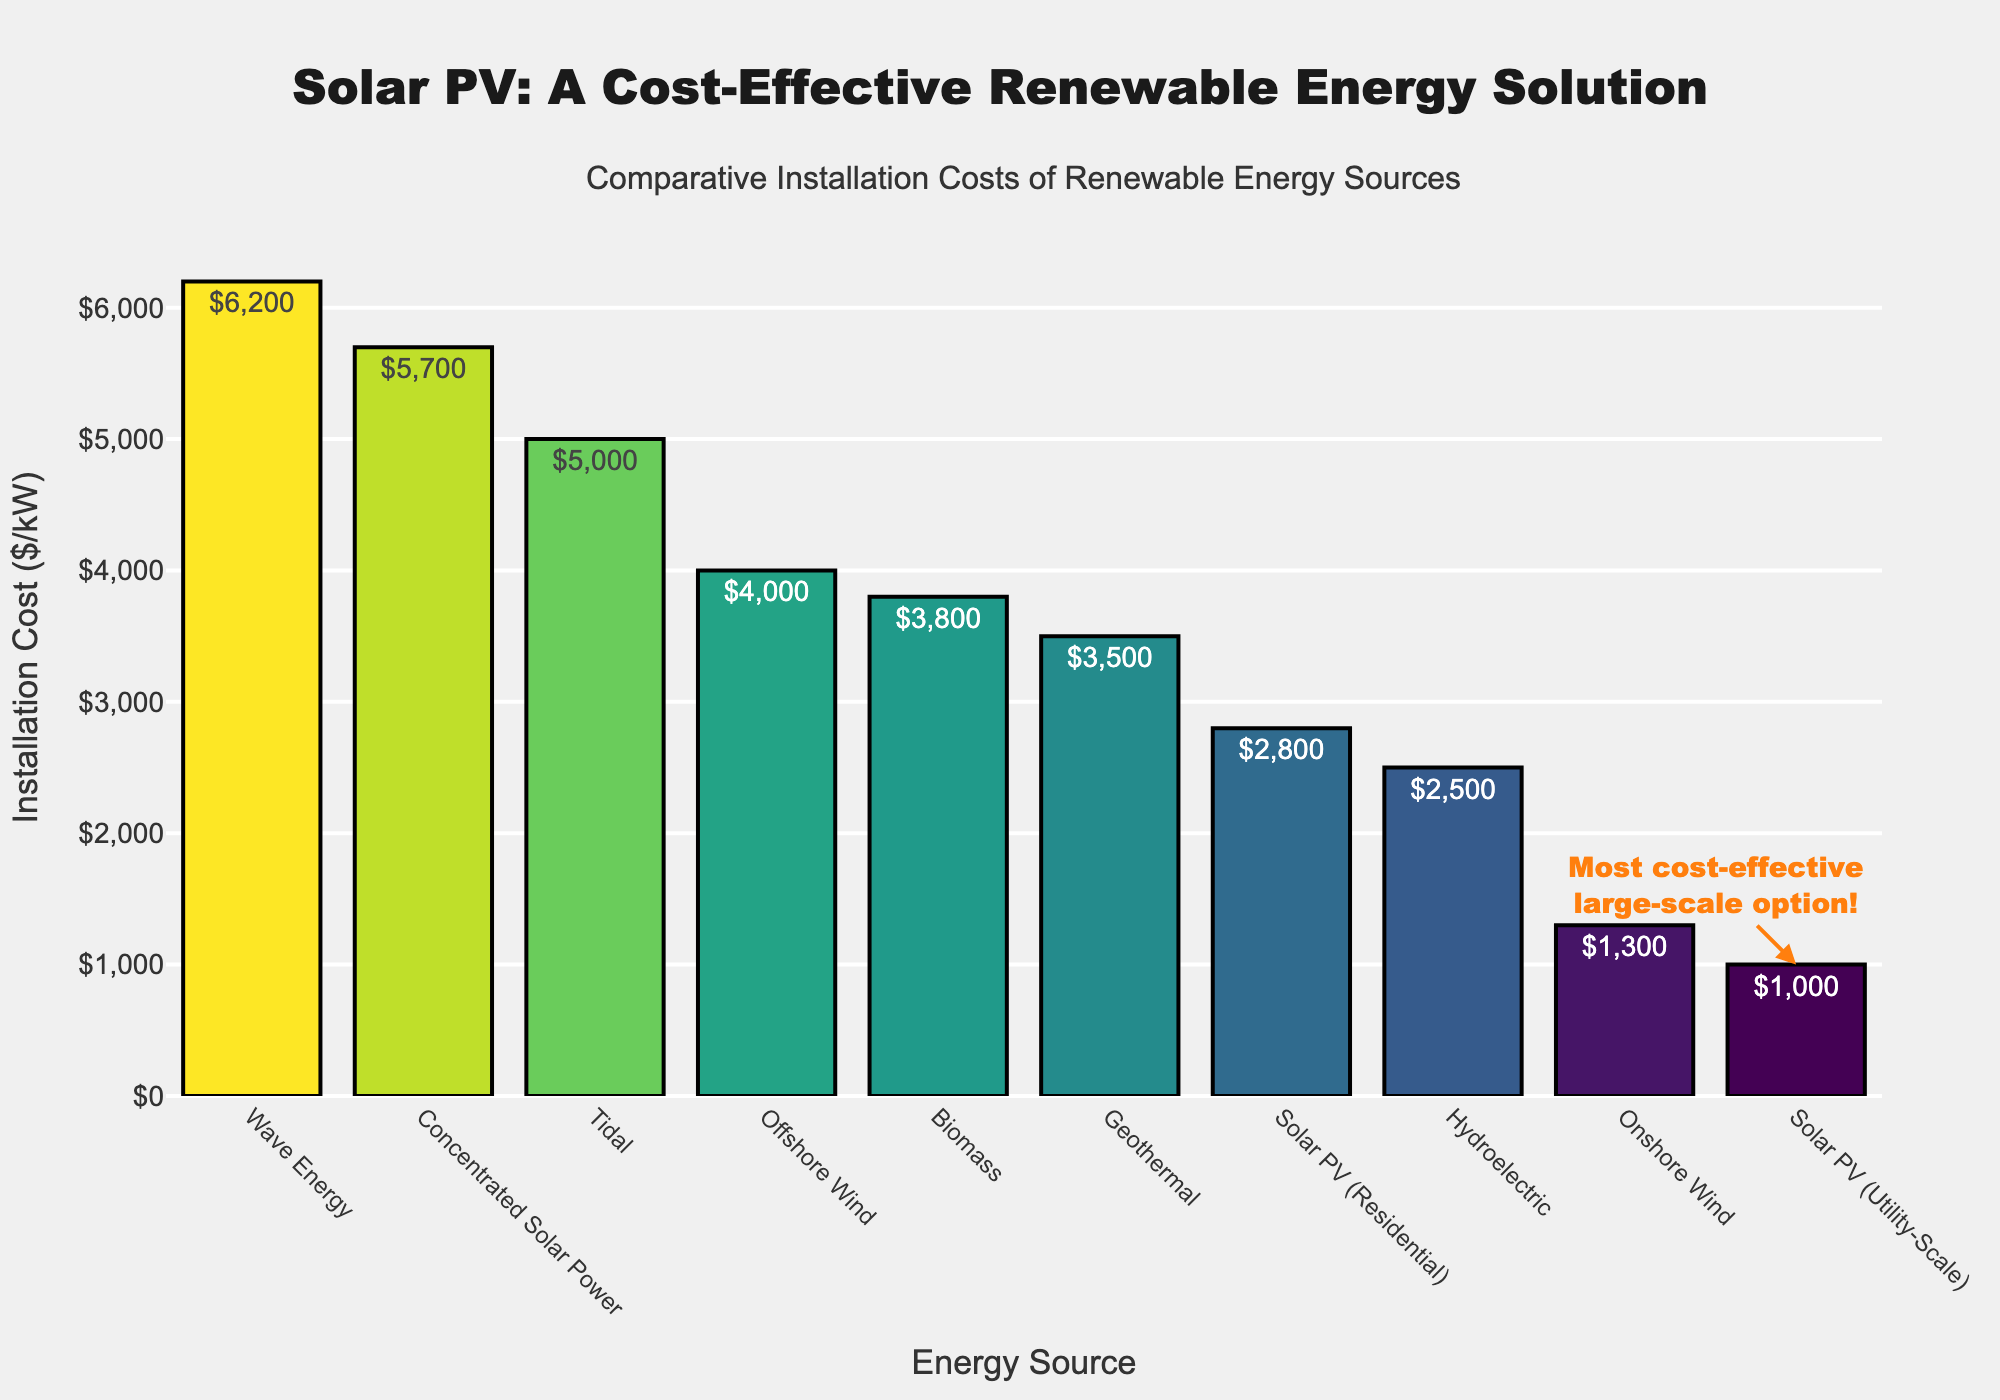What is the total installation cost for Solar PV (Utility-Scale) and Solar PV (Residential)? To find the total installation cost, add the costs for Solar PV (Utility-Scale) and Solar PV (Residential). That is $1000/kW + $2800/kW = $3800/kW.
Answer: $3800/kW Which energy source has the highest installation cost? By looking at the heights of the bars, Wave Energy has the tallest bar indicating it has the highest installation cost.
Answer: Wave Energy How much higher is the installation cost of Wave Energy compared to Onshore Wind? Wave Energy has an installation cost of $6200/kW and Onshore Wind has $1300/kW. The difference is $6200/kW - $1300/kW = $4900/kW.
Answer: $4900/kW Which energy source is most cost-effective for large-scale installations? According to the annotation in the plot, Solar PV (Utility-Scale) is highlighted as the most cost-effective large-scale option.
Answer: Solar PV (Utility-Scale) What is the average installation cost of all the renewable energy sources listed? To calculate the average, sum all the installation costs and divide by the number of sources: ($1000 + $2800 + $1300 + $4000 + $2500 + $3500 + $3800 + $5700 + $5000 + $6200) / 10 = $35,800 / 10 = $3580/kW.
Answer: $3580/kW How does the installation cost of Concentrated Solar Power compare to Hydroelectric? Concentrated Solar Power has an installation cost of $5700/kW, while Hydroelectric has $2500/kW. Thus, Concentrated Solar Power is $5700/kW - $2500/kW = $3200/kW more expensive.
Answer: $3200/kW more expensive Which energy sources have installation costs greater than $3000/kW? By inspecting the bars with heights above the $3000/kW mark, the energy sources are Offshore Wind, Geothermal, Biomass, Concentrated Solar Power, Tidal, and Wave Energy.
Answer: Offshore Wind, Geothermal, Biomass, Concentrated Solar Power, Tidal, Wave Energy What is the relative difference in cost between Solar PV (Residential) and Geothermal? Solar PV (Residential) has an installation cost of $2800/kW, and Geothermal has $3500/kW. The relative difference is ($3500 - $2800) / $2800 x 100% ≈ 25%.
Answer: ≈ 25% What is the median installation cost of the listed renewable energy sources? To find the median, the installation costs must be ordered and the middle value selected: $1000, $1300, $2500, $2800, $3500, $3800, $4000, $5000, $5700, $6200. The middle values are $3500 and $3800, so the median is ($3500 + $3800) / 2 = $3650/kW.
Answer: $3650/kW 